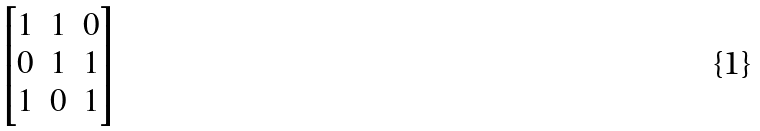Convert formula to latex. <formula><loc_0><loc_0><loc_500><loc_500>\begin{bmatrix} 1 & 1 & 0 \\ 0 & 1 & 1 \\ 1 & 0 & 1 \\ \end{bmatrix}</formula> 